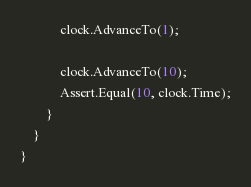Convert code to text. <code><loc_0><loc_0><loc_500><loc_500><_C#_>            clock.AdvanceTo(1);

            clock.AdvanceTo(10);
            Assert.Equal(10, clock.Time);
        }
    }
}
</code> 